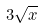<formula> <loc_0><loc_0><loc_500><loc_500>3 \sqrt { x }</formula> 